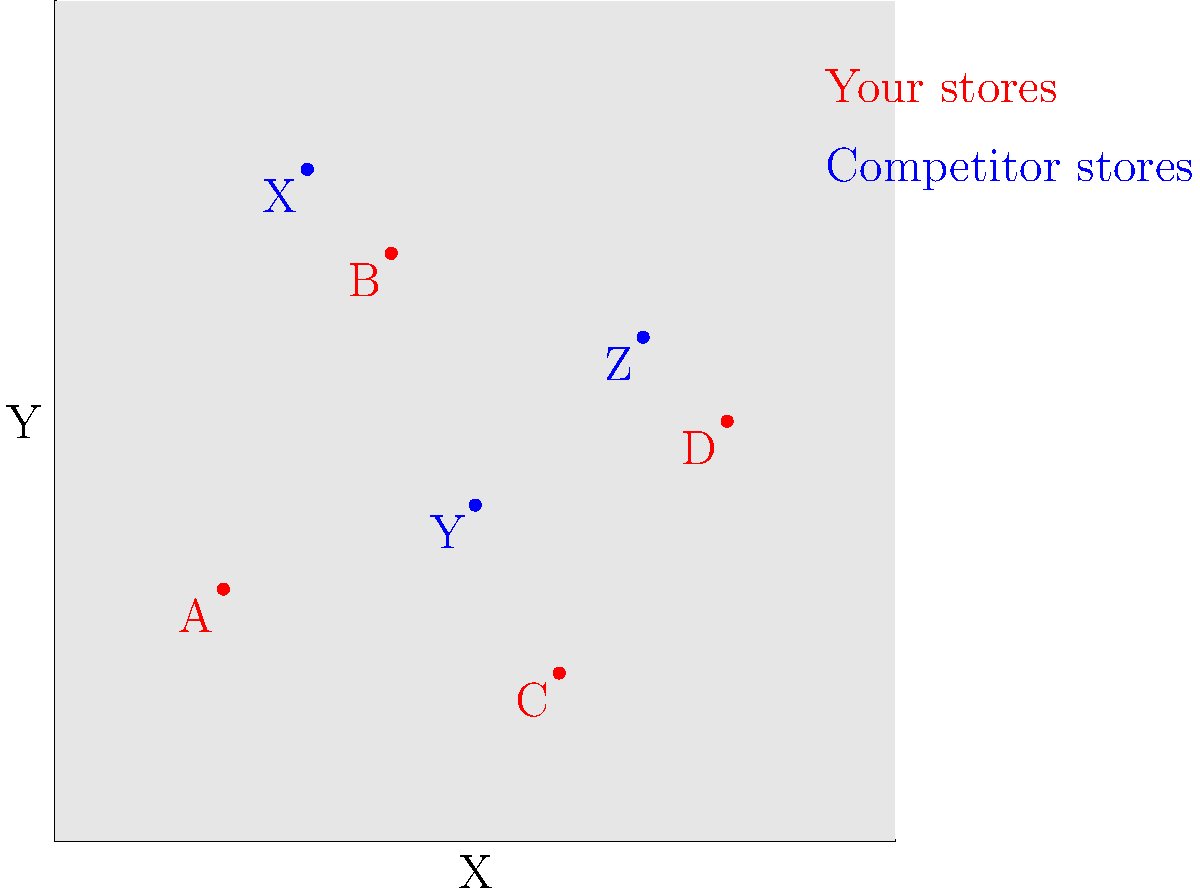As the CEO of a retail conglomerate considering a merger, you're analyzing the geographical distribution of stores. The map shows your stores (red) and a competitor's stores (blue). Which of your stores is positioned to potentially cannibalize the most business from the competitor's locations if the merger proceeds? To determine which of our stores is best positioned to cannibalize business from the competitor's locations, we need to consider the proximity of each of our stores to the competitor's stores. Let's analyze each of our stores:

1. Store A (2,3):
   - Relatively far from all competitor stores
   - Closest to competitor store Y, but still at a significant distance

2. Store B (4,7):
   - Close to competitor store X (3,8)
   - Moderate distance from competitor store Y

3. Store C (6,2):
   - Relatively isolated from competitor stores
   - Closest to competitor store Y, but still at a moderate distance

4. Store D (8,5):
   - Close to competitor store Z (7,6)
   - Moderate distance from competitor store Y

Comparing these, we can see that Store B and Store D are the closest to competitor stores. However, Store B is in a unique position:

- It's very close to competitor store X
- It's also at a moderate distance from competitor store Y

This positioning allows Store B to potentially cannibalize business from two competitor stores, whereas Store D is mainly positioned to affect only one competitor store (Z).

Therefore, Store B (4,7) is best positioned to potentially cannibalize the most business from the competitor's locations if the merger proceeds.
Answer: Store B (4,7) 